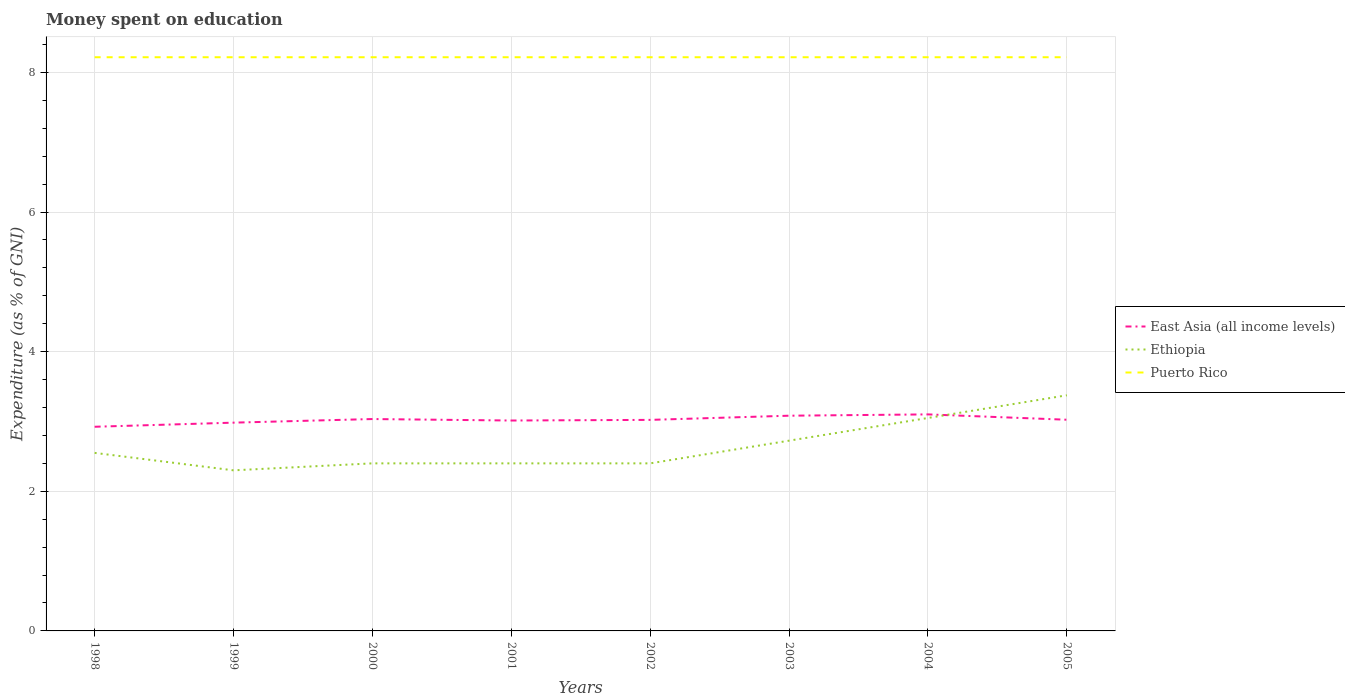Does the line corresponding to Puerto Rico intersect with the line corresponding to Ethiopia?
Your response must be concise. No. Is the number of lines equal to the number of legend labels?
Offer a terse response. Yes. Across all years, what is the maximum amount of money spent on education in East Asia (all income levels)?
Give a very brief answer. 2.92. What is the difference between the highest and the second highest amount of money spent on education in Ethiopia?
Offer a very short reply. 1.07. Is the amount of money spent on education in Puerto Rico strictly greater than the amount of money spent on education in Ethiopia over the years?
Provide a succinct answer. No. How many years are there in the graph?
Ensure brevity in your answer.  8. What is the difference between two consecutive major ticks on the Y-axis?
Your response must be concise. 2. Are the values on the major ticks of Y-axis written in scientific E-notation?
Your answer should be very brief. No. Does the graph contain any zero values?
Keep it short and to the point. No. Where does the legend appear in the graph?
Provide a succinct answer. Center right. How many legend labels are there?
Give a very brief answer. 3. What is the title of the graph?
Keep it short and to the point. Money spent on education. Does "Bulgaria" appear as one of the legend labels in the graph?
Your answer should be compact. No. What is the label or title of the Y-axis?
Your answer should be compact. Expenditure (as % of GNI). What is the Expenditure (as % of GNI) in East Asia (all income levels) in 1998?
Give a very brief answer. 2.92. What is the Expenditure (as % of GNI) in Ethiopia in 1998?
Offer a terse response. 2.55. What is the Expenditure (as % of GNI) in Puerto Rico in 1998?
Ensure brevity in your answer.  8.22. What is the Expenditure (as % of GNI) of East Asia (all income levels) in 1999?
Provide a short and direct response. 2.98. What is the Expenditure (as % of GNI) in Puerto Rico in 1999?
Offer a very short reply. 8.22. What is the Expenditure (as % of GNI) in East Asia (all income levels) in 2000?
Keep it short and to the point. 3.03. What is the Expenditure (as % of GNI) in Puerto Rico in 2000?
Provide a short and direct response. 8.22. What is the Expenditure (as % of GNI) in East Asia (all income levels) in 2001?
Your response must be concise. 3.01. What is the Expenditure (as % of GNI) in Puerto Rico in 2001?
Offer a very short reply. 8.22. What is the Expenditure (as % of GNI) in East Asia (all income levels) in 2002?
Provide a short and direct response. 3.02. What is the Expenditure (as % of GNI) of Ethiopia in 2002?
Your answer should be compact. 2.4. What is the Expenditure (as % of GNI) of Puerto Rico in 2002?
Your response must be concise. 8.22. What is the Expenditure (as % of GNI) in East Asia (all income levels) in 2003?
Make the answer very short. 3.08. What is the Expenditure (as % of GNI) of Ethiopia in 2003?
Provide a succinct answer. 2.72. What is the Expenditure (as % of GNI) of Puerto Rico in 2003?
Offer a very short reply. 8.22. What is the Expenditure (as % of GNI) of East Asia (all income levels) in 2004?
Provide a short and direct response. 3.1. What is the Expenditure (as % of GNI) in Ethiopia in 2004?
Offer a terse response. 3.05. What is the Expenditure (as % of GNI) in Puerto Rico in 2004?
Your response must be concise. 8.22. What is the Expenditure (as % of GNI) in East Asia (all income levels) in 2005?
Ensure brevity in your answer.  3.02. What is the Expenditure (as % of GNI) in Ethiopia in 2005?
Keep it short and to the point. 3.37. What is the Expenditure (as % of GNI) of Puerto Rico in 2005?
Make the answer very short. 8.22. Across all years, what is the maximum Expenditure (as % of GNI) in East Asia (all income levels)?
Offer a very short reply. 3.1. Across all years, what is the maximum Expenditure (as % of GNI) in Ethiopia?
Make the answer very short. 3.37. Across all years, what is the maximum Expenditure (as % of GNI) of Puerto Rico?
Make the answer very short. 8.22. Across all years, what is the minimum Expenditure (as % of GNI) of East Asia (all income levels)?
Your answer should be very brief. 2.92. Across all years, what is the minimum Expenditure (as % of GNI) of Ethiopia?
Make the answer very short. 2.3. Across all years, what is the minimum Expenditure (as % of GNI) in Puerto Rico?
Make the answer very short. 8.22. What is the total Expenditure (as % of GNI) in East Asia (all income levels) in the graph?
Provide a short and direct response. 24.19. What is the total Expenditure (as % of GNI) in Ethiopia in the graph?
Offer a terse response. 21.2. What is the total Expenditure (as % of GNI) in Puerto Rico in the graph?
Your response must be concise. 65.73. What is the difference between the Expenditure (as % of GNI) in East Asia (all income levels) in 1998 and that in 1999?
Your answer should be compact. -0.06. What is the difference between the Expenditure (as % of GNI) in Ethiopia in 1998 and that in 1999?
Offer a very short reply. 0.25. What is the difference between the Expenditure (as % of GNI) in Puerto Rico in 1998 and that in 1999?
Keep it short and to the point. 0. What is the difference between the Expenditure (as % of GNI) of East Asia (all income levels) in 1998 and that in 2000?
Provide a short and direct response. -0.11. What is the difference between the Expenditure (as % of GNI) of Puerto Rico in 1998 and that in 2000?
Offer a terse response. 0. What is the difference between the Expenditure (as % of GNI) in East Asia (all income levels) in 1998 and that in 2001?
Ensure brevity in your answer.  -0.09. What is the difference between the Expenditure (as % of GNI) in Ethiopia in 1998 and that in 2001?
Give a very brief answer. 0.15. What is the difference between the Expenditure (as % of GNI) in East Asia (all income levels) in 1998 and that in 2002?
Your answer should be compact. -0.1. What is the difference between the Expenditure (as % of GNI) in Puerto Rico in 1998 and that in 2002?
Offer a terse response. 0. What is the difference between the Expenditure (as % of GNI) in East Asia (all income levels) in 1998 and that in 2003?
Provide a succinct answer. -0.16. What is the difference between the Expenditure (as % of GNI) of Ethiopia in 1998 and that in 2003?
Give a very brief answer. -0.17. What is the difference between the Expenditure (as % of GNI) in East Asia (all income levels) in 1998 and that in 2004?
Your answer should be compact. -0.18. What is the difference between the Expenditure (as % of GNI) of Ethiopia in 1998 and that in 2004?
Your response must be concise. -0.5. What is the difference between the Expenditure (as % of GNI) of East Asia (all income levels) in 1998 and that in 2005?
Make the answer very short. -0.1. What is the difference between the Expenditure (as % of GNI) in Ethiopia in 1998 and that in 2005?
Keep it short and to the point. -0.82. What is the difference between the Expenditure (as % of GNI) in East Asia (all income levels) in 1999 and that in 2000?
Provide a short and direct response. -0.05. What is the difference between the Expenditure (as % of GNI) of Ethiopia in 1999 and that in 2000?
Your response must be concise. -0.1. What is the difference between the Expenditure (as % of GNI) of East Asia (all income levels) in 1999 and that in 2001?
Offer a terse response. -0.03. What is the difference between the Expenditure (as % of GNI) in Puerto Rico in 1999 and that in 2001?
Offer a terse response. 0. What is the difference between the Expenditure (as % of GNI) in East Asia (all income levels) in 1999 and that in 2002?
Make the answer very short. -0.04. What is the difference between the Expenditure (as % of GNI) of Ethiopia in 1999 and that in 2002?
Your answer should be compact. -0.1. What is the difference between the Expenditure (as % of GNI) in Puerto Rico in 1999 and that in 2002?
Make the answer very short. 0. What is the difference between the Expenditure (as % of GNI) in East Asia (all income levels) in 1999 and that in 2003?
Make the answer very short. -0.1. What is the difference between the Expenditure (as % of GNI) of Ethiopia in 1999 and that in 2003?
Provide a short and direct response. -0.42. What is the difference between the Expenditure (as % of GNI) of East Asia (all income levels) in 1999 and that in 2004?
Give a very brief answer. -0.12. What is the difference between the Expenditure (as % of GNI) in Ethiopia in 1999 and that in 2004?
Offer a very short reply. -0.75. What is the difference between the Expenditure (as % of GNI) in Puerto Rico in 1999 and that in 2004?
Offer a terse response. 0. What is the difference between the Expenditure (as % of GNI) in East Asia (all income levels) in 1999 and that in 2005?
Give a very brief answer. -0.04. What is the difference between the Expenditure (as % of GNI) of Ethiopia in 1999 and that in 2005?
Make the answer very short. -1.07. What is the difference between the Expenditure (as % of GNI) in East Asia (all income levels) in 2000 and that in 2001?
Your response must be concise. 0.02. What is the difference between the Expenditure (as % of GNI) of East Asia (all income levels) in 2000 and that in 2002?
Provide a succinct answer. 0.01. What is the difference between the Expenditure (as % of GNI) of Ethiopia in 2000 and that in 2002?
Provide a short and direct response. 0. What is the difference between the Expenditure (as % of GNI) in East Asia (all income levels) in 2000 and that in 2003?
Provide a succinct answer. -0.05. What is the difference between the Expenditure (as % of GNI) of Ethiopia in 2000 and that in 2003?
Your answer should be very brief. -0.33. What is the difference between the Expenditure (as % of GNI) in East Asia (all income levels) in 2000 and that in 2004?
Offer a very short reply. -0.07. What is the difference between the Expenditure (as % of GNI) in Ethiopia in 2000 and that in 2004?
Ensure brevity in your answer.  -0.65. What is the difference between the Expenditure (as % of GNI) in Puerto Rico in 2000 and that in 2004?
Provide a succinct answer. 0. What is the difference between the Expenditure (as % of GNI) in East Asia (all income levels) in 2000 and that in 2005?
Provide a short and direct response. 0.01. What is the difference between the Expenditure (as % of GNI) in Ethiopia in 2000 and that in 2005?
Make the answer very short. -0.97. What is the difference between the Expenditure (as % of GNI) of East Asia (all income levels) in 2001 and that in 2002?
Provide a short and direct response. -0.01. What is the difference between the Expenditure (as % of GNI) in Puerto Rico in 2001 and that in 2002?
Ensure brevity in your answer.  0. What is the difference between the Expenditure (as % of GNI) in East Asia (all income levels) in 2001 and that in 2003?
Your answer should be compact. -0.07. What is the difference between the Expenditure (as % of GNI) of Ethiopia in 2001 and that in 2003?
Offer a terse response. -0.33. What is the difference between the Expenditure (as % of GNI) of East Asia (all income levels) in 2001 and that in 2004?
Your answer should be compact. -0.09. What is the difference between the Expenditure (as % of GNI) of Ethiopia in 2001 and that in 2004?
Provide a succinct answer. -0.65. What is the difference between the Expenditure (as % of GNI) of Puerto Rico in 2001 and that in 2004?
Keep it short and to the point. 0. What is the difference between the Expenditure (as % of GNI) of East Asia (all income levels) in 2001 and that in 2005?
Make the answer very short. -0.01. What is the difference between the Expenditure (as % of GNI) of Ethiopia in 2001 and that in 2005?
Make the answer very short. -0.97. What is the difference between the Expenditure (as % of GNI) of East Asia (all income levels) in 2002 and that in 2003?
Offer a terse response. -0.06. What is the difference between the Expenditure (as % of GNI) in Ethiopia in 2002 and that in 2003?
Keep it short and to the point. -0.33. What is the difference between the Expenditure (as % of GNI) of East Asia (all income levels) in 2002 and that in 2004?
Provide a succinct answer. -0.08. What is the difference between the Expenditure (as % of GNI) of Ethiopia in 2002 and that in 2004?
Offer a very short reply. -0.65. What is the difference between the Expenditure (as % of GNI) in East Asia (all income levels) in 2002 and that in 2005?
Your answer should be compact. -0. What is the difference between the Expenditure (as % of GNI) of Ethiopia in 2002 and that in 2005?
Your answer should be compact. -0.97. What is the difference between the Expenditure (as % of GNI) of Puerto Rico in 2002 and that in 2005?
Provide a succinct answer. 0. What is the difference between the Expenditure (as % of GNI) in East Asia (all income levels) in 2003 and that in 2004?
Give a very brief answer. -0.02. What is the difference between the Expenditure (as % of GNI) of Ethiopia in 2003 and that in 2004?
Make the answer very short. -0.33. What is the difference between the Expenditure (as % of GNI) in East Asia (all income levels) in 2003 and that in 2005?
Offer a very short reply. 0.06. What is the difference between the Expenditure (as % of GNI) in Ethiopia in 2003 and that in 2005?
Your answer should be compact. -0.65. What is the difference between the Expenditure (as % of GNI) of Puerto Rico in 2003 and that in 2005?
Offer a very short reply. 0. What is the difference between the Expenditure (as % of GNI) of East Asia (all income levels) in 2004 and that in 2005?
Keep it short and to the point. 0.08. What is the difference between the Expenditure (as % of GNI) of Ethiopia in 2004 and that in 2005?
Your answer should be very brief. -0.33. What is the difference between the Expenditure (as % of GNI) of East Asia (all income levels) in 1998 and the Expenditure (as % of GNI) of Ethiopia in 1999?
Make the answer very short. 0.62. What is the difference between the Expenditure (as % of GNI) in East Asia (all income levels) in 1998 and the Expenditure (as % of GNI) in Puerto Rico in 1999?
Your answer should be very brief. -5.29. What is the difference between the Expenditure (as % of GNI) in Ethiopia in 1998 and the Expenditure (as % of GNI) in Puerto Rico in 1999?
Your answer should be compact. -5.67. What is the difference between the Expenditure (as % of GNI) of East Asia (all income levels) in 1998 and the Expenditure (as % of GNI) of Ethiopia in 2000?
Your answer should be compact. 0.52. What is the difference between the Expenditure (as % of GNI) in East Asia (all income levels) in 1998 and the Expenditure (as % of GNI) in Puerto Rico in 2000?
Provide a succinct answer. -5.29. What is the difference between the Expenditure (as % of GNI) of Ethiopia in 1998 and the Expenditure (as % of GNI) of Puerto Rico in 2000?
Provide a succinct answer. -5.67. What is the difference between the Expenditure (as % of GNI) of East Asia (all income levels) in 1998 and the Expenditure (as % of GNI) of Ethiopia in 2001?
Your answer should be compact. 0.52. What is the difference between the Expenditure (as % of GNI) in East Asia (all income levels) in 1998 and the Expenditure (as % of GNI) in Puerto Rico in 2001?
Your answer should be compact. -5.29. What is the difference between the Expenditure (as % of GNI) of Ethiopia in 1998 and the Expenditure (as % of GNI) of Puerto Rico in 2001?
Ensure brevity in your answer.  -5.67. What is the difference between the Expenditure (as % of GNI) in East Asia (all income levels) in 1998 and the Expenditure (as % of GNI) in Ethiopia in 2002?
Keep it short and to the point. 0.52. What is the difference between the Expenditure (as % of GNI) in East Asia (all income levels) in 1998 and the Expenditure (as % of GNI) in Puerto Rico in 2002?
Give a very brief answer. -5.29. What is the difference between the Expenditure (as % of GNI) in Ethiopia in 1998 and the Expenditure (as % of GNI) in Puerto Rico in 2002?
Your answer should be very brief. -5.67. What is the difference between the Expenditure (as % of GNI) of East Asia (all income levels) in 1998 and the Expenditure (as % of GNI) of Ethiopia in 2003?
Keep it short and to the point. 0.2. What is the difference between the Expenditure (as % of GNI) in East Asia (all income levels) in 1998 and the Expenditure (as % of GNI) in Puerto Rico in 2003?
Provide a short and direct response. -5.29. What is the difference between the Expenditure (as % of GNI) in Ethiopia in 1998 and the Expenditure (as % of GNI) in Puerto Rico in 2003?
Provide a succinct answer. -5.67. What is the difference between the Expenditure (as % of GNI) of East Asia (all income levels) in 1998 and the Expenditure (as % of GNI) of Ethiopia in 2004?
Offer a terse response. -0.13. What is the difference between the Expenditure (as % of GNI) of East Asia (all income levels) in 1998 and the Expenditure (as % of GNI) of Puerto Rico in 2004?
Provide a succinct answer. -5.29. What is the difference between the Expenditure (as % of GNI) of Ethiopia in 1998 and the Expenditure (as % of GNI) of Puerto Rico in 2004?
Your response must be concise. -5.67. What is the difference between the Expenditure (as % of GNI) of East Asia (all income levels) in 1998 and the Expenditure (as % of GNI) of Ethiopia in 2005?
Provide a succinct answer. -0.45. What is the difference between the Expenditure (as % of GNI) in East Asia (all income levels) in 1998 and the Expenditure (as % of GNI) in Puerto Rico in 2005?
Ensure brevity in your answer.  -5.29. What is the difference between the Expenditure (as % of GNI) in Ethiopia in 1998 and the Expenditure (as % of GNI) in Puerto Rico in 2005?
Provide a succinct answer. -5.67. What is the difference between the Expenditure (as % of GNI) of East Asia (all income levels) in 1999 and the Expenditure (as % of GNI) of Ethiopia in 2000?
Your answer should be very brief. 0.58. What is the difference between the Expenditure (as % of GNI) of East Asia (all income levels) in 1999 and the Expenditure (as % of GNI) of Puerto Rico in 2000?
Provide a succinct answer. -5.23. What is the difference between the Expenditure (as % of GNI) of Ethiopia in 1999 and the Expenditure (as % of GNI) of Puerto Rico in 2000?
Your answer should be compact. -5.92. What is the difference between the Expenditure (as % of GNI) of East Asia (all income levels) in 1999 and the Expenditure (as % of GNI) of Ethiopia in 2001?
Make the answer very short. 0.58. What is the difference between the Expenditure (as % of GNI) of East Asia (all income levels) in 1999 and the Expenditure (as % of GNI) of Puerto Rico in 2001?
Make the answer very short. -5.23. What is the difference between the Expenditure (as % of GNI) of Ethiopia in 1999 and the Expenditure (as % of GNI) of Puerto Rico in 2001?
Offer a very short reply. -5.92. What is the difference between the Expenditure (as % of GNI) of East Asia (all income levels) in 1999 and the Expenditure (as % of GNI) of Ethiopia in 2002?
Your response must be concise. 0.58. What is the difference between the Expenditure (as % of GNI) of East Asia (all income levels) in 1999 and the Expenditure (as % of GNI) of Puerto Rico in 2002?
Keep it short and to the point. -5.23. What is the difference between the Expenditure (as % of GNI) in Ethiopia in 1999 and the Expenditure (as % of GNI) in Puerto Rico in 2002?
Provide a short and direct response. -5.92. What is the difference between the Expenditure (as % of GNI) in East Asia (all income levels) in 1999 and the Expenditure (as % of GNI) in Ethiopia in 2003?
Keep it short and to the point. 0.26. What is the difference between the Expenditure (as % of GNI) of East Asia (all income levels) in 1999 and the Expenditure (as % of GNI) of Puerto Rico in 2003?
Offer a terse response. -5.23. What is the difference between the Expenditure (as % of GNI) of Ethiopia in 1999 and the Expenditure (as % of GNI) of Puerto Rico in 2003?
Your answer should be compact. -5.92. What is the difference between the Expenditure (as % of GNI) of East Asia (all income levels) in 1999 and the Expenditure (as % of GNI) of Ethiopia in 2004?
Keep it short and to the point. -0.07. What is the difference between the Expenditure (as % of GNI) of East Asia (all income levels) in 1999 and the Expenditure (as % of GNI) of Puerto Rico in 2004?
Provide a succinct answer. -5.23. What is the difference between the Expenditure (as % of GNI) of Ethiopia in 1999 and the Expenditure (as % of GNI) of Puerto Rico in 2004?
Keep it short and to the point. -5.92. What is the difference between the Expenditure (as % of GNI) in East Asia (all income levels) in 1999 and the Expenditure (as % of GNI) in Ethiopia in 2005?
Your answer should be very brief. -0.39. What is the difference between the Expenditure (as % of GNI) of East Asia (all income levels) in 1999 and the Expenditure (as % of GNI) of Puerto Rico in 2005?
Give a very brief answer. -5.23. What is the difference between the Expenditure (as % of GNI) in Ethiopia in 1999 and the Expenditure (as % of GNI) in Puerto Rico in 2005?
Ensure brevity in your answer.  -5.92. What is the difference between the Expenditure (as % of GNI) in East Asia (all income levels) in 2000 and the Expenditure (as % of GNI) in Ethiopia in 2001?
Offer a terse response. 0.63. What is the difference between the Expenditure (as % of GNI) of East Asia (all income levels) in 2000 and the Expenditure (as % of GNI) of Puerto Rico in 2001?
Your answer should be very brief. -5.18. What is the difference between the Expenditure (as % of GNI) of Ethiopia in 2000 and the Expenditure (as % of GNI) of Puerto Rico in 2001?
Offer a very short reply. -5.82. What is the difference between the Expenditure (as % of GNI) of East Asia (all income levels) in 2000 and the Expenditure (as % of GNI) of Ethiopia in 2002?
Your answer should be compact. 0.63. What is the difference between the Expenditure (as % of GNI) of East Asia (all income levels) in 2000 and the Expenditure (as % of GNI) of Puerto Rico in 2002?
Your answer should be very brief. -5.18. What is the difference between the Expenditure (as % of GNI) in Ethiopia in 2000 and the Expenditure (as % of GNI) in Puerto Rico in 2002?
Provide a succinct answer. -5.82. What is the difference between the Expenditure (as % of GNI) of East Asia (all income levels) in 2000 and the Expenditure (as % of GNI) of Ethiopia in 2003?
Make the answer very short. 0.31. What is the difference between the Expenditure (as % of GNI) in East Asia (all income levels) in 2000 and the Expenditure (as % of GNI) in Puerto Rico in 2003?
Make the answer very short. -5.18. What is the difference between the Expenditure (as % of GNI) of Ethiopia in 2000 and the Expenditure (as % of GNI) of Puerto Rico in 2003?
Provide a short and direct response. -5.82. What is the difference between the Expenditure (as % of GNI) in East Asia (all income levels) in 2000 and the Expenditure (as % of GNI) in Ethiopia in 2004?
Your response must be concise. -0.02. What is the difference between the Expenditure (as % of GNI) in East Asia (all income levels) in 2000 and the Expenditure (as % of GNI) in Puerto Rico in 2004?
Keep it short and to the point. -5.18. What is the difference between the Expenditure (as % of GNI) in Ethiopia in 2000 and the Expenditure (as % of GNI) in Puerto Rico in 2004?
Your answer should be compact. -5.82. What is the difference between the Expenditure (as % of GNI) of East Asia (all income levels) in 2000 and the Expenditure (as % of GNI) of Ethiopia in 2005?
Your response must be concise. -0.34. What is the difference between the Expenditure (as % of GNI) in East Asia (all income levels) in 2000 and the Expenditure (as % of GNI) in Puerto Rico in 2005?
Give a very brief answer. -5.18. What is the difference between the Expenditure (as % of GNI) in Ethiopia in 2000 and the Expenditure (as % of GNI) in Puerto Rico in 2005?
Provide a succinct answer. -5.82. What is the difference between the Expenditure (as % of GNI) of East Asia (all income levels) in 2001 and the Expenditure (as % of GNI) of Ethiopia in 2002?
Your response must be concise. 0.61. What is the difference between the Expenditure (as % of GNI) of East Asia (all income levels) in 2001 and the Expenditure (as % of GNI) of Puerto Rico in 2002?
Your answer should be compact. -5.2. What is the difference between the Expenditure (as % of GNI) in Ethiopia in 2001 and the Expenditure (as % of GNI) in Puerto Rico in 2002?
Provide a succinct answer. -5.82. What is the difference between the Expenditure (as % of GNI) in East Asia (all income levels) in 2001 and the Expenditure (as % of GNI) in Ethiopia in 2003?
Make the answer very short. 0.29. What is the difference between the Expenditure (as % of GNI) in East Asia (all income levels) in 2001 and the Expenditure (as % of GNI) in Puerto Rico in 2003?
Ensure brevity in your answer.  -5.2. What is the difference between the Expenditure (as % of GNI) of Ethiopia in 2001 and the Expenditure (as % of GNI) of Puerto Rico in 2003?
Give a very brief answer. -5.82. What is the difference between the Expenditure (as % of GNI) in East Asia (all income levels) in 2001 and the Expenditure (as % of GNI) in Ethiopia in 2004?
Keep it short and to the point. -0.04. What is the difference between the Expenditure (as % of GNI) of East Asia (all income levels) in 2001 and the Expenditure (as % of GNI) of Puerto Rico in 2004?
Make the answer very short. -5.2. What is the difference between the Expenditure (as % of GNI) in Ethiopia in 2001 and the Expenditure (as % of GNI) in Puerto Rico in 2004?
Make the answer very short. -5.82. What is the difference between the Expenditure (as % of GNI) of East Asia (all income levels) in 2001 and the Expenditure (as % of GNI) of Ethiopia in 2005?
Your response must be concise. -0.36. What is the difference between the Expenditure (as % of GNI) of East Asia (all income levels) in 2001 and the Expenditure (as % of GNI) of Puerto Rico in 2005?
Your answer should be very brief. -5.2. What is the difference between the Expenditure (as % of GNI) of Ethiopia in 2001 and the Expenditure (as % of GNI) of Puerto Rico in 2005?
Offer a terse response. -5.82. What is the difference between the Expenditure (as % of GNI) of East Asia (all income levels) in 2002 and the Expenditure (as % of GNI) of Ethiopia in 2003?
Make the answer very short. 0.3. What is the difference between the Expenditure (as % of GNI) in East Asia (all income levels) in 2002 and the Expenditure (as % of GNI) in Puerto Rico in 2003?
Your answer should be compact. -5.19. What is the difference between the Expenditure (as % of GNI) of Ethiopia in 2002 and the Expenditure (as % of GNI) of Puerto Rico in 2003?
Offer a very short reply. -5.82. What is the difference between the Expenditure (as % of GNI) of East Asia (all income levels) in 2002 and the Expenditure (as % of GNI) of Ethiopia in 2004?
Your answer should be very brief. -0.03. What is the difference between the Expenditure (as % of GNI) of East Asia (all income levels) in 2002 and the Expenditure (as % of GNI) of Puerto Rico in 2004?
Your answer should be compact. -5.19. What is the difference between the Expenditure (as % of GNI) of Ethiopia in 2002 and the Expenditure (as % of GNI) of Puerto Rico in 2004?
Give a very brief answer. -5.82. What is the difference between the Expenditure (as % of GNI) in East Asia (all income levels) in 2002 and the Expenditure (as % of GNI) in Ethiopia in 2005?
Your answer should be very brief. -0.35. What is the difference between the Expenditure (as % of GNI) of East Asia (all income levels) in 2002 and the Expenditure (as % of GNI) of Puerto Rico in 2005?
Your response must be concise. -5.19. What is the difference between the Expenditure (as % of GNI) of Ethiopia in 2002 and the Expenditure (as % of GNI) of Puerto Rico in 2005?
Your answer should be compact. -5.82. What is the difference between the Expenditure (as % of GNI) in East Asia (all income levels) in 2003 and the Expenditure (as % of GNI) in Ethiopia in 2004?
Your answer should be compact. 0.03. What is the difference between the Expenditure (as % of GNI) of East Asia (all income levels) in 2003 and the Expenditure (as % of GNI) of Puerto Rico in 2004?
Ensure brevity in your answer.  -5.13. What is the difference between the Expenditure (as % of GNI) in Ethiopia in 2003 and the Expenditure (as % of GNI) in Puerto Rico in 2004?
Keep it short and to the point. -5.49. What is the difference between the Expenditure (as % of GNI) of East Asia (all income levels) in 2003 and the Expenditure (as % of GNI) of Ethiopia in 2005?
Make the answer very short. -0.29. What is the difference between the Expenditure (as % of GNI) of East Asia (all income levels) in 2003 and the Expenditure (as % of GNI) of Puerto Rico in 2005?
Your answer should be compact. -5.13. What is the difference between the Expenditure (as % of GNI) in Ethiopia in 2003 and the Expenditure (as % of GNI) in Puerto Rico in 2005?
Your answer should be very brief. -5.49. What is the difference between the Expenditure (as % of GNI) of East Asia (all income levels) in 2004 and the Expenditure (as % of GNI) of Ethiopia in 2005?
Make the answer very short. -0.27. What is the difference between the Expenditure (as % of GNI) in East Asia (all income levels) in 2004 and the Expenditure (as % of GNI) in Puerto Rico in 2005?
Offer a very short reply. -5.12. What is the difference between the Expenditure (as % of GNI) of Ethiopia in 2004 and the Expenditure (as % of GNI) of Puerto Rico in 2005?
Your answer should be very brief. -5.17. What is the average Expenditure (as % of GNI) of East Asia (all income levels) per year?
Provide a succinct answer. 3.02. What is the average Expenditure (as % of GNI) in Ethiopia per year?
Keep it short and to the point. 2.65. What is the average Expenditure (as % of GNI) in Puerto Rico per year?
Your answer should be compact. 8.22. In the year 1998, what is the difference between the Expenditure (as % of GNI) of East Asia (all income levels) and Expenditure (as % of GNI) of Ethiopia?
Your answer should be compact. 0.37. In the year 1998, what is the difference between the Expenditure (as % of GNI) of East Asia (all income levels) and Expenditure (as % of GNI) of Puerto Rico?
Make the answer very short. -5.29. In the year 1998, what is the difference between the Expenditure (as % of GNI) of Ethiopia and Expenditure (as % of GNI) of Puerto Rico?
Your response must be concise. -5.67. In the year 1999, what is the difference between the Expenditure (as % of GNI) of East Asia (all income levels) and Expenditure (as % of GNI) of Ethiopia?
Give a very brief answer. 0.68. In the year 1999, what is the difference between the Expenditure (as % of GNI) in East Asia (all income levels) and Expenditure (as % of GNI) in Puerto Rico?
Provide a short and direct response. -5.23. In the year 1999, what is the difference between the Expenditure (as % of GNI) in Ethiopia and Expenditure (as % of GNI) in Puerto Rico?
Give a very brief answer. -5.92. In the year 2000, what is the difference between the Expenditure (as % of GNI) in East Asia (all income levels) and Expenditure (as % of GNI) in Ethiopia?
Keep it short and to the point. 0.63. In the year 2000, what is the difference between the Expenditure (as % of GNI) of East Asia (all income levels) and Expenditure (as % of GNI) of Puerto Rico?
Make the answer very short. -5.18. In the year 2000, what is the difference between the Expenditure (as % of GNI) of Ethiopia and Expenditure (as % of GNI) of Puerto Rico?
Provide a succinct answer. -5.82. In the year 2001, what is the difference between the Expenditure (as % of GNI) of East Asia (all income levels) and Expenditure (as % of GNI) of Ethiopia?
Offer a very short reply. 0.61. In the year 2001, what is the difference between the Expenditure (as % of GNI) of East Asia (all income levels) and Expenditure (as % of GNI) of Puerto Rico?
Your response must be concise. -5.2. In the year 2001, what is the difference between the Expenditure (as % of GNI) of Ethiopia and Expenditure (as % of GNI) of Puerto Rico?
Ensure brevity in your answer.  -5.82. In the year 2002, what is the difference between the Expenditure (as % of GNI) in East Asia (all income levels) and Expenditure (as % of GNI) in Ethiopia?
Give a very brief answer. 0.62. In the year 2002, what is the difference between the Expenditure (as % of GNI) of East Asia (all income levels) and Expenditure (as % of GNI) of Puerto Rico?
Keep it short and to the point. -5.19. In the year 2002, what is the difference between the Expenditure (as % of GNI) in Ethiopia and Expenditure (as % of GNI) in Puerto Rico?
Your response must be concise. -5.82. In the year 2003, what is the difference between the Expenditure (as % of GNI) in East Asia (all income levels) and Expenditure (as % of GNI) in Ethiopia?
Keep it short and to the point. 0.36. In the year 2003, what is the difference between the Expenditure (as % of GNI) in East Asia (all income levels) and Expenditure (as % of GNI) in Puerto Rico?
Your response must be concise. -5.13. In the year 2003, what is the difference between the Expenditure (as % of GNI) in Ethiopia and Expenditure (as % of GNI) in Puerto Rico?
Your response must be concise. -5.49. In the year 2004, what is the difference between the Expenditure (as % of GNI) in East Asia (all income levels) and Expenditure (as % of GNI) in Ethiopia?
Offer a terse response. 0.05. In the year 2004, what is the difference between the Expenditure (as % of GNI) of East Asia (all income levels) and Expenditure (as % of GNI) of Puerto Rico?
Ensure brevity in your answer.  -5.12. In the year 2004, what is the difference between the Expenditure (as % of GNI) of Ethiopia and Expenditure (as % of GNI) of Puerto Rico?
Provide a short and direct response. -5.17. In the year 2005, what is the difference between the Expenditure (as % of GNI) in East Asia (all income levels) and Expenditure (as % of GNI) in Ethiopia?
Offer a terse response. -0.35. In the year 2005, what is the difference between the Expenditure (as % of GNI) of East Asia (all income levels) and Expenditure (as % of GNI) of Puerto Rico?
Your answer should be compact. -5.19. In the year 2005, what is the difference between the Expenditure (as % of GNI) in Ethiopia and Expenditure (as % of GNI) in Puerto Rico?
Your answer should be compact. -4.84. What is the ratio of the Expenditure (as % of GNI) of East Asia (all income levels) in 1998 to that in 1999?
Ensure brevity in your answer.  0.98. What is the ratio of the Expenditure (as % of GNI) of Ethiopia in 1998 to that in 1999?
Provide a succinct answer. 1.11. What is the ratio of the Expenditure (as % of GNI) in East Asia (all income levels) in 1998 to that in 2000?
Make the answer very short. 0.96. What is the ratio of the Expenditure (as % of GNI) of Puerto Rico in 1998 to that in 2000?
Offer a terse response. 1. What is the ratio of the Expenditure (as % of GNI) of East Asia (all income levels) in 1998 to that in 2001?
Provide a succinct answer. 0.97. What is the ratio of the Expenditure (as % of GNI) of Ethiopia in 1998 to that in 2001?
Offer a very short reply. 1.06. What is the ratio of the Expenditure (as % of GNI) of Puerto Rico in 1998 to that in 2001?
Offer a very short reply. 1. What is the ratio of the Expenditure (as % of GNI) in East Asia (all income levels) in 1998 to that in 2002?
Provide a short and direct response. 0.97. What is the ratio of the Expenditure (as % of GNI) in Puerto Rico in 1998 to that in 2002?
Provide a succinct answer. 1. What is the ratio of the Expenditure (as % of GNI) in East Asia (all income levels) in 1998 to that in 2003?
Make the answer very short. 0.95. What is the ratio of the Expenditure (as % of GNI) of Ethiopia in 1998 to that in 2003?
Offer a terse response. 0.94. What is the ratio of the Expenditure (as % of GNI) in East Asia (all income levels) in 1998 to that in 2004?
Your response must be concise. 0.94. What is the ratio of the Expenditure (as % of GNI) in Ethiopia in 1998 to that in 2004?
Your response must be concise. 0.84. What is the ratio of the Expenditure (as % of GNI) in East Asia (all income levels) in 1998 to that in 2005?
Keep it short and to the point. 0.97. What is the ratio of the Expenditure (as % of GNI) of Ethiopia in 1998 to that in 2005?
Your response must be concise. 0.76. What is the ratio of the Expenditure (as % of GNI) of Puerto Rico in 1998 to that in 2005?
Your answer should be compact. 1. What is the ratio of the Expenditure (as % of GNI) of East Asia (all income levels) in 1999 to that in 2000?
Offer a very short reply. 0.98. What is the ratio of the Expenditure (as % of GNI) in Ethiopia in 1999 to that in 2000?
Your response must be concise. 0.96. What is the ratio of the Expenditure (as % of GNI) in Puerto Rico in 1999 to that in 2000?
Ensure brevity in your answer.  1. What is the ratio of the Expenditure (as % of GNI) in East Asia (all income levels) in 1999 to that in 2001?
Give a very brief answer. 0.99. What is the ratio of the Expenditure (as % of GNI) in Ethiopia in 1999 to that in 2001?
Offer a terse response. 0.96. What is the ratio of the Expenditure (as % of GNI) of Ethiopia in 1999 to that in 2002?
Offer a terse response. 0.96. What is the ratio of the Expenditure (as % of GNI) of Puerto Rico in 1999 to that in 2002?
Provide a short and direct response. 1. What is the ratio of the Expenditure (as % of GNI) of Ethiopia in 1999 to that in 2003?
Your answer should be very brief. 0.84. What is the ratio of the Expenditure (as % of GNI) in Puerto Rico in 1999 to that in 2003?
Your response must be concise. 1. What is the ratio of the Expenditure (as % of GNI) of East Asia (all income levels) in 1999 to that in 2004?
Make the answer very short. 0.96. What is the ratio of the Expenditure (as % of GNI) in Ethiopia in 1999 to that in 2004?
Keep it short and to the point. 0.75. What is the ratio of the Expenditure (as % of GNI) of Puerto Rico in 1999 to that in 2004?
Give a very brief answer. 1. What is the ratio of the Expenditure (as % of GNI) in East Asia (all income levels) in 1999 to that in 2005?
Give a very brief answer. 0.99. What is the ratio of the Expenditure (as % of GNI) in Ethiopia in 1999 to that in 2005?
Keep it short and to the point. 0.68. What is the ratio of the Expenditure (as % of GNI) in Ethiopia in 2000 to that in 2001?
Offer a very short reply. 1. What is the ratio of the Expenditure (as % of GNI) of East Asia (all income levels) in 2000 to that in 2003?
Your answer should be compact. 0.98. What is the ratio of the Expenditure (as % of GNI) of Ethiopia in 2000 to that in 2003?
Give a very brief answer. 0.88. What is the ratio of the Expenditure (as % of GNI) of East Asia (all income levels) in 2000 to that in 2004?
Offer a very short reply. 0.98. What is the ratio of the Expenditure (as % of GNI) in Ethiopia in 2000 to that in 2004?
Provide a short and direct response. 0.79. What is the ratio of the Expenditure (as % of GNI) of Puerto Rico in 2000 to that in 2004?
Provide a short and direct response. 1. What is the ratio of the Expenditure (as % of GNI) of East Asia (all income levels) in 2000 to that in 2005?
Offer a terse response. 1. What is the ratio of the Expenditure (as % of GNI) in Ethiopia in 2000 to that in 2005?
Your response must be concise. 0.71. What is the ratio of the Expenditure (as % of GNI) in Puerto Rico in 2000 to that in 2005?
Offer a terse response. 1. What is the ratio of the Expenditure (as % of GNI) of Puerto Rico in 2001 to that in 2002?
Make the answer very short. 1. What is the ratio of the Expenditure (as % of GNI) in East Asia (all income levels) in 2001 to that in 2003?
Ensure brevity in your answer.  0.98. What is the ratio of the Expenditure (as % of GNI) of Ethiopia in 2001 to that in 2003?
Give a very brief answer. 0.88. What is the ratio of the Expenditure (as % of GNI) of East Asia (all income levels) in 2001 to that in 2004?
Offer a terse response. 0.97. What is the ratio of the Expenditure (as % of GNI) in Ethiopia in 2001 to that in 2004?
Give a very brief answer. 0.79. What is the ratio of the Expenditure (as % of GNI) in Ethiopia in 2001 to that in 2005?
Provide a short and direct response. 0.71. What is the ratio of the Expenditure (as % of GNI) in East Asia (all income levels) in 2002 to that in 2003?
Your answer should be compact. 0.98. What is the ratio of the Expenditure (as % of GNI) in Ethiopia in 2002 to that in 2003?
Your answer should be very brief. 0.88. What is the ratio of the Expenditure (as % of GNI) of East Asia (all income levels) in 2002 to that in 2004?
Ensure brevity in your answer.  0.97. What is the ratio of the Expenditure (as % of GNI) of Ethiopia in 2002 to that in 2004?
Offer a terse response. 0.79. What is the ratio of the Expenditure (as % of GNI) of Puerto Rico in 2002 to that in 2004?
Provide a short and direct response. 1. What is the ratio of the Expenditure (as % of GNI) in Ethiopia in 2002 to that in 2005?
Your answer should be very brief. 0.71. What is the ratio of the Expenditure (as % of GNI) in Puerto Rico in 2002 to that in 2005?
Offer a very short reply. 1. What is the ratio of the Expenditure (as % of GNI) of East Asia (all income levels) in 2003 to that in 2004?
Keep it short and to the point. 0.99. What is the ratio of the Expenditure (as % of GNI) of Ethiopia in 2003 to that in 2004?
Your answer should be very brief. 0.89. What is the ratio of the Expenditure (as % of GNI) of Puerto Rico in 2003 to that in 2004?
Provide a succinct answer. 1. What is the ratio of the Expenditure (as % of GNI) in East Asia (all income levels) in 2003 to that in 2005?
Offer a terse response. 1.02. What is the ratio of the Expenditure (as % of GNI) in Ethiopia in 2003 to that in 2005?
Your answer should be compact. 0.81. What is the ratio of the Expenditure (as % of GNI) of Puerto Rico in 2003 to that in 2005?
Keep it short and to the point. 1. What is the ratio of the Expenditure (as % of GNI) of East Asia (all income levels) in 2004 to that in 2005?
Offer a very short reply. 1.03. What is the ratio of the Expenditure (as % of GNI) of Ethiopia in 2004 to that in 2005?
Provide a succinct answer. 0.9. What is the difference between the highest and the second highest Expenditure (as % of GNI) of East Asia (all income levels)?
Your answer should be very brief. 0.02. What is the difference between the highest and the second highest Expenditure (as % of GNI) in Ethiopia?
Provide a short and direct response. 0.33. What is the difference between the highest and the second highest Expenditure (as % of GNI) in Puerto Rico?
Offer a very short reply. 0. What is the difference between the highest and the lowest Expenditure (as % of GNI) in East Asia (all income levels)?
Your response must be concise. 0.18. What is the difference between the highest and the lowest Expenditure (as % of GNI) of Ethiopia?
Keep it short and to the point. 1.07. What is the difference between the highest and the lowest Expenditure (as % of GNI) of Puerto Rico?
Your response must be concise. 0. 